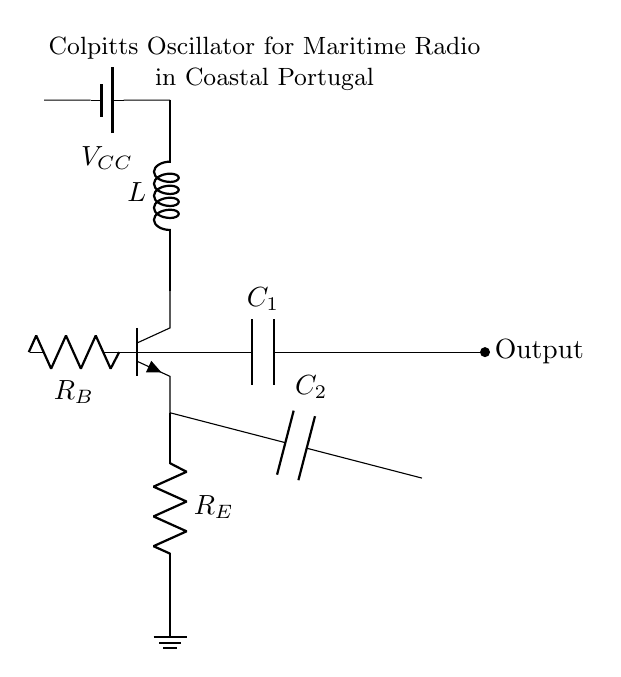What type of oscillator is shown in the circuit? The circuit diagram depicts a Colpitts oscillator, characterized by its use of two capacitors and an inductor to produce oscillations.
Answer: Colpitts oscillator How many capacitors are present in the circuit? The circuit includes two capacitors, labeled C1 and C2, which are essential for generating the required frequency of oscillation.
Answer: Two What is the function of the inductor in the circuit? The inductor, labeled L, works together with the capacitors to determine the oscillation frequency of the Colpitts oscillator by storing magnetic energy.
Answer: Determine frequency What could be the role of the resistor RB in the circuit? Resistor RB is commonly used for biasing the transistor, which helps to set the operating point and ensures proper functioning of the oscillator.
Answer: Biasing Which component is responsible for outputting the signal? The output is taken from the point connected to capacitor C1, where the oscillating signal can be extracted for further use.
Answer: Capacitor C1 How would the oscillation frequency be affected if the value of capacitors C1 or C2 is increased? Increasing either capacitor's value would lower the oscillation frequency because the frequency in a Colpitts oscillator is inversely proportional to the capacitance values used.
Answer: Lower frequency Why is the Colpitts oscillator particularly suitable for maritime radio communication? The Colpitts oscillator's ability to produce stable and adjustable frequencies makes it ideal for maritime radio, where precise communication frequencies are essential.
Answer: Stable frequencies 